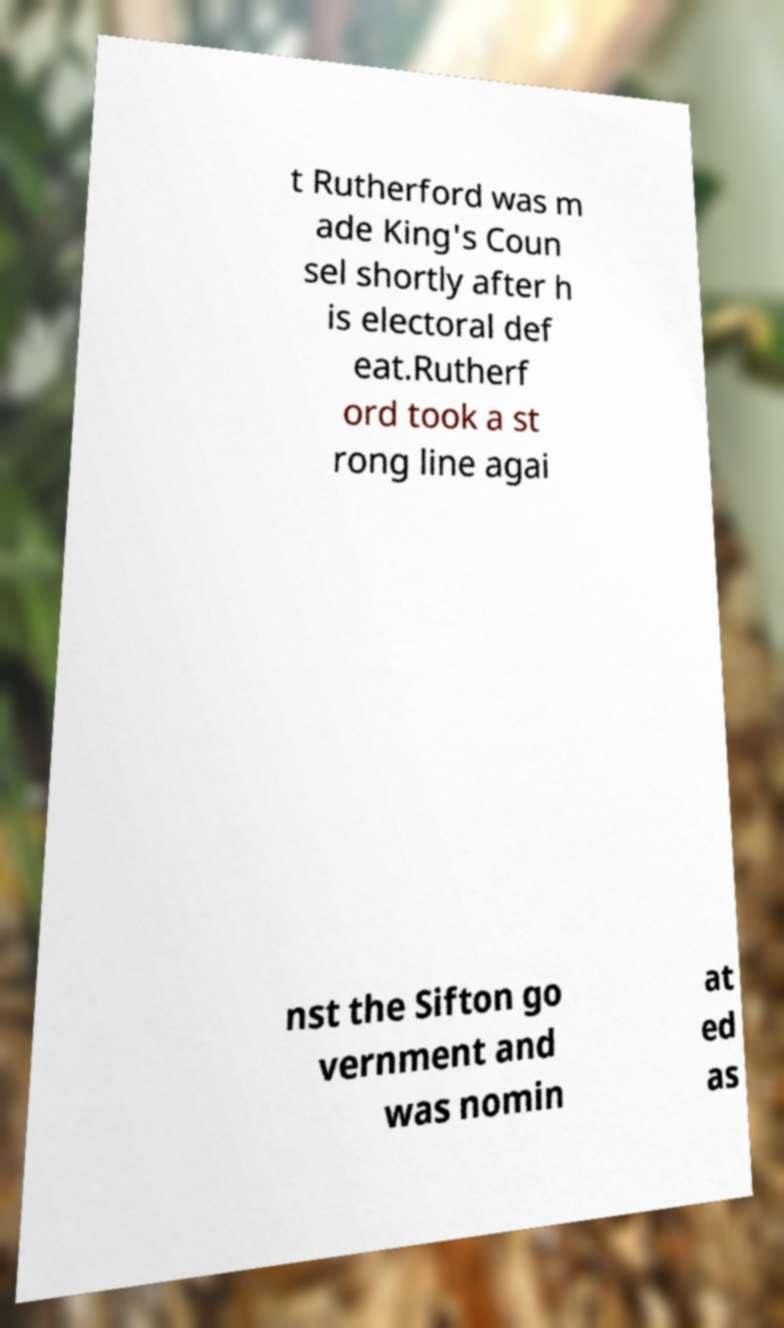Could you assist in decoding the text presented in this image and type it out clearly? t Rutherford was m ade King's Coun sel shortly after h is electoral def eat.Rutherf ord took a st rong line agai nst the Sifton go vernment and was nomin at ed as 